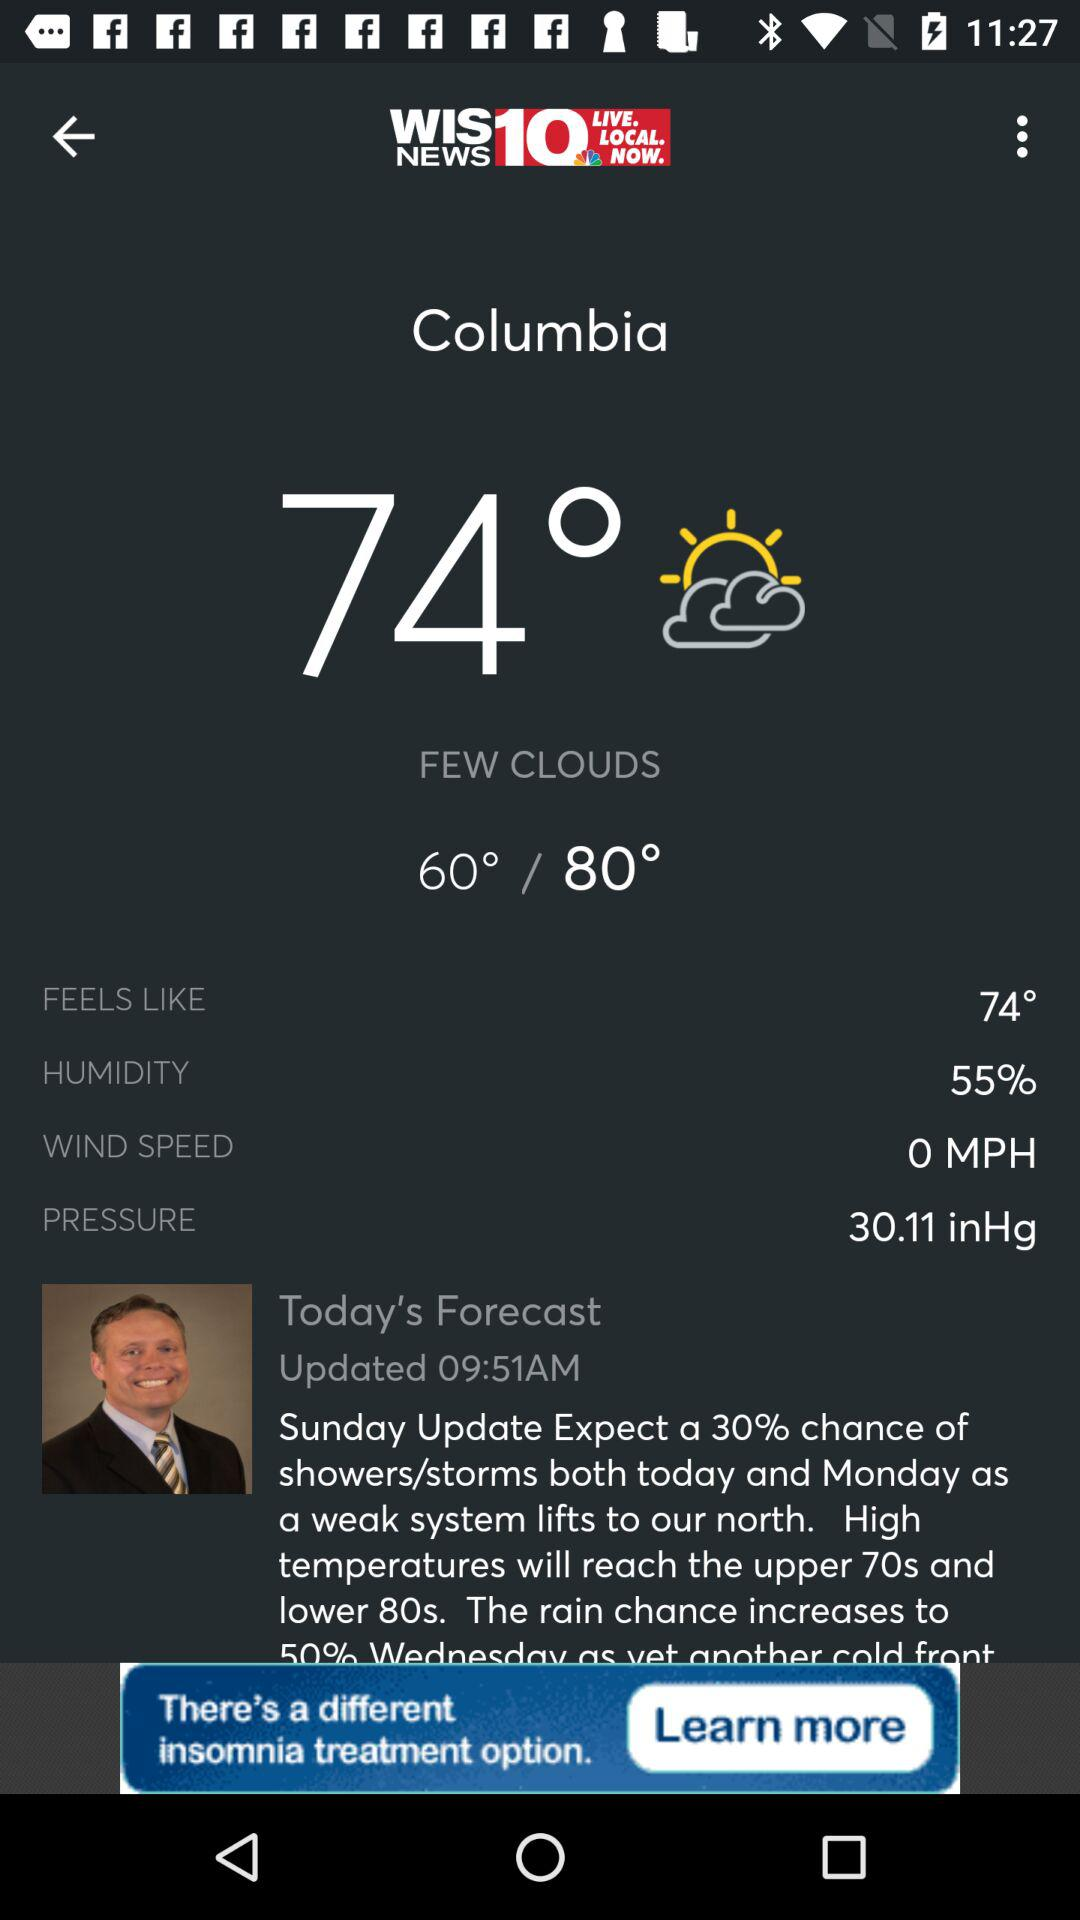What is the humidity percentage?
Answer the question using a single word or phrase. 55% 